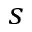Convert formula to latex. <formula><loc_0><loc_0><loc_500><loc_500>s</formula> 